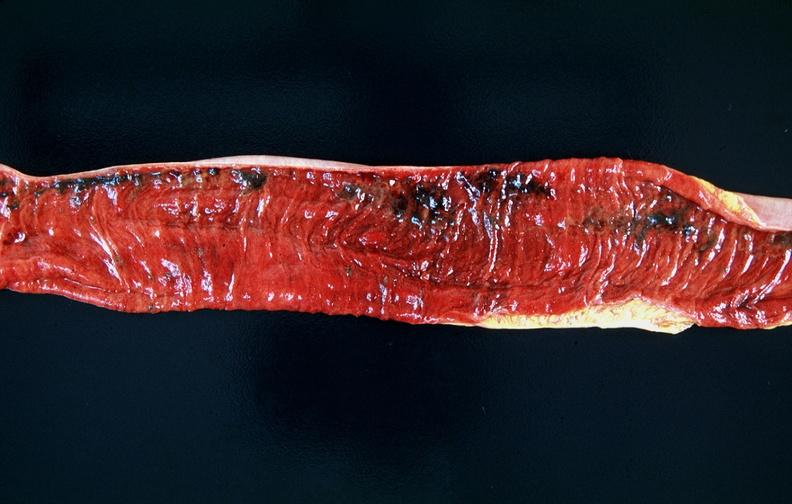what does this image show?
Answer the question using a single word or phrase. Small intestine 